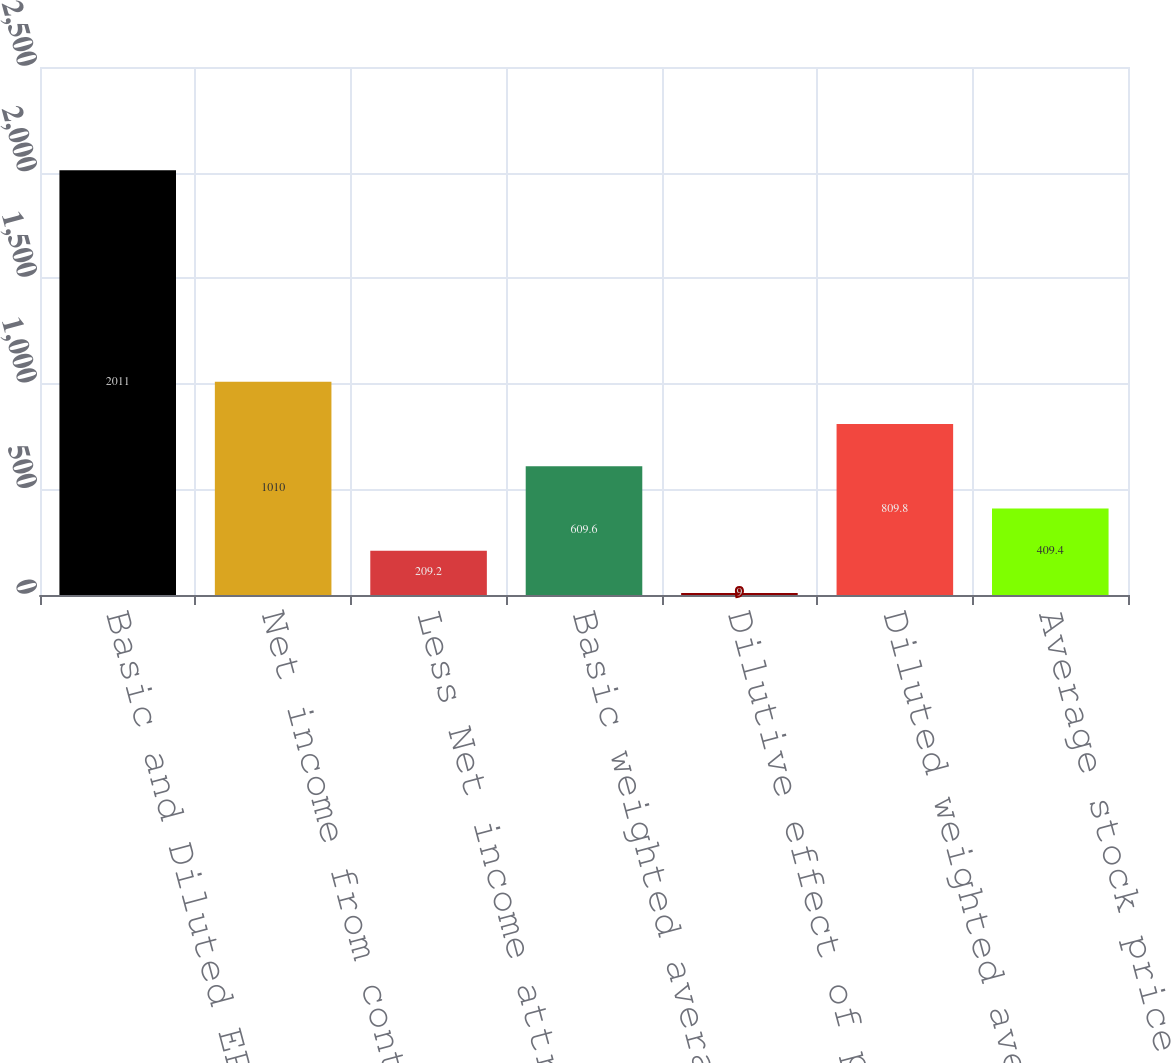Convert chart. <chart><loc_0><loc_0><loc_500><loc_500><bar_chart><fcel>Basic and Diluted EPS<fcel>Net income from continuing<fcel>Less Net income attributable<fcel>Basic weighted average common<fcel>Dilutive effect of potentially<fcel>Diluted weighted average<fcel>Average stock price used to<nl><fcel>2011<fcel>1010<fcel>209.2<fcel>609.6<fcel>9<fcel>809.8<fcel>409.4<nl></chart> 